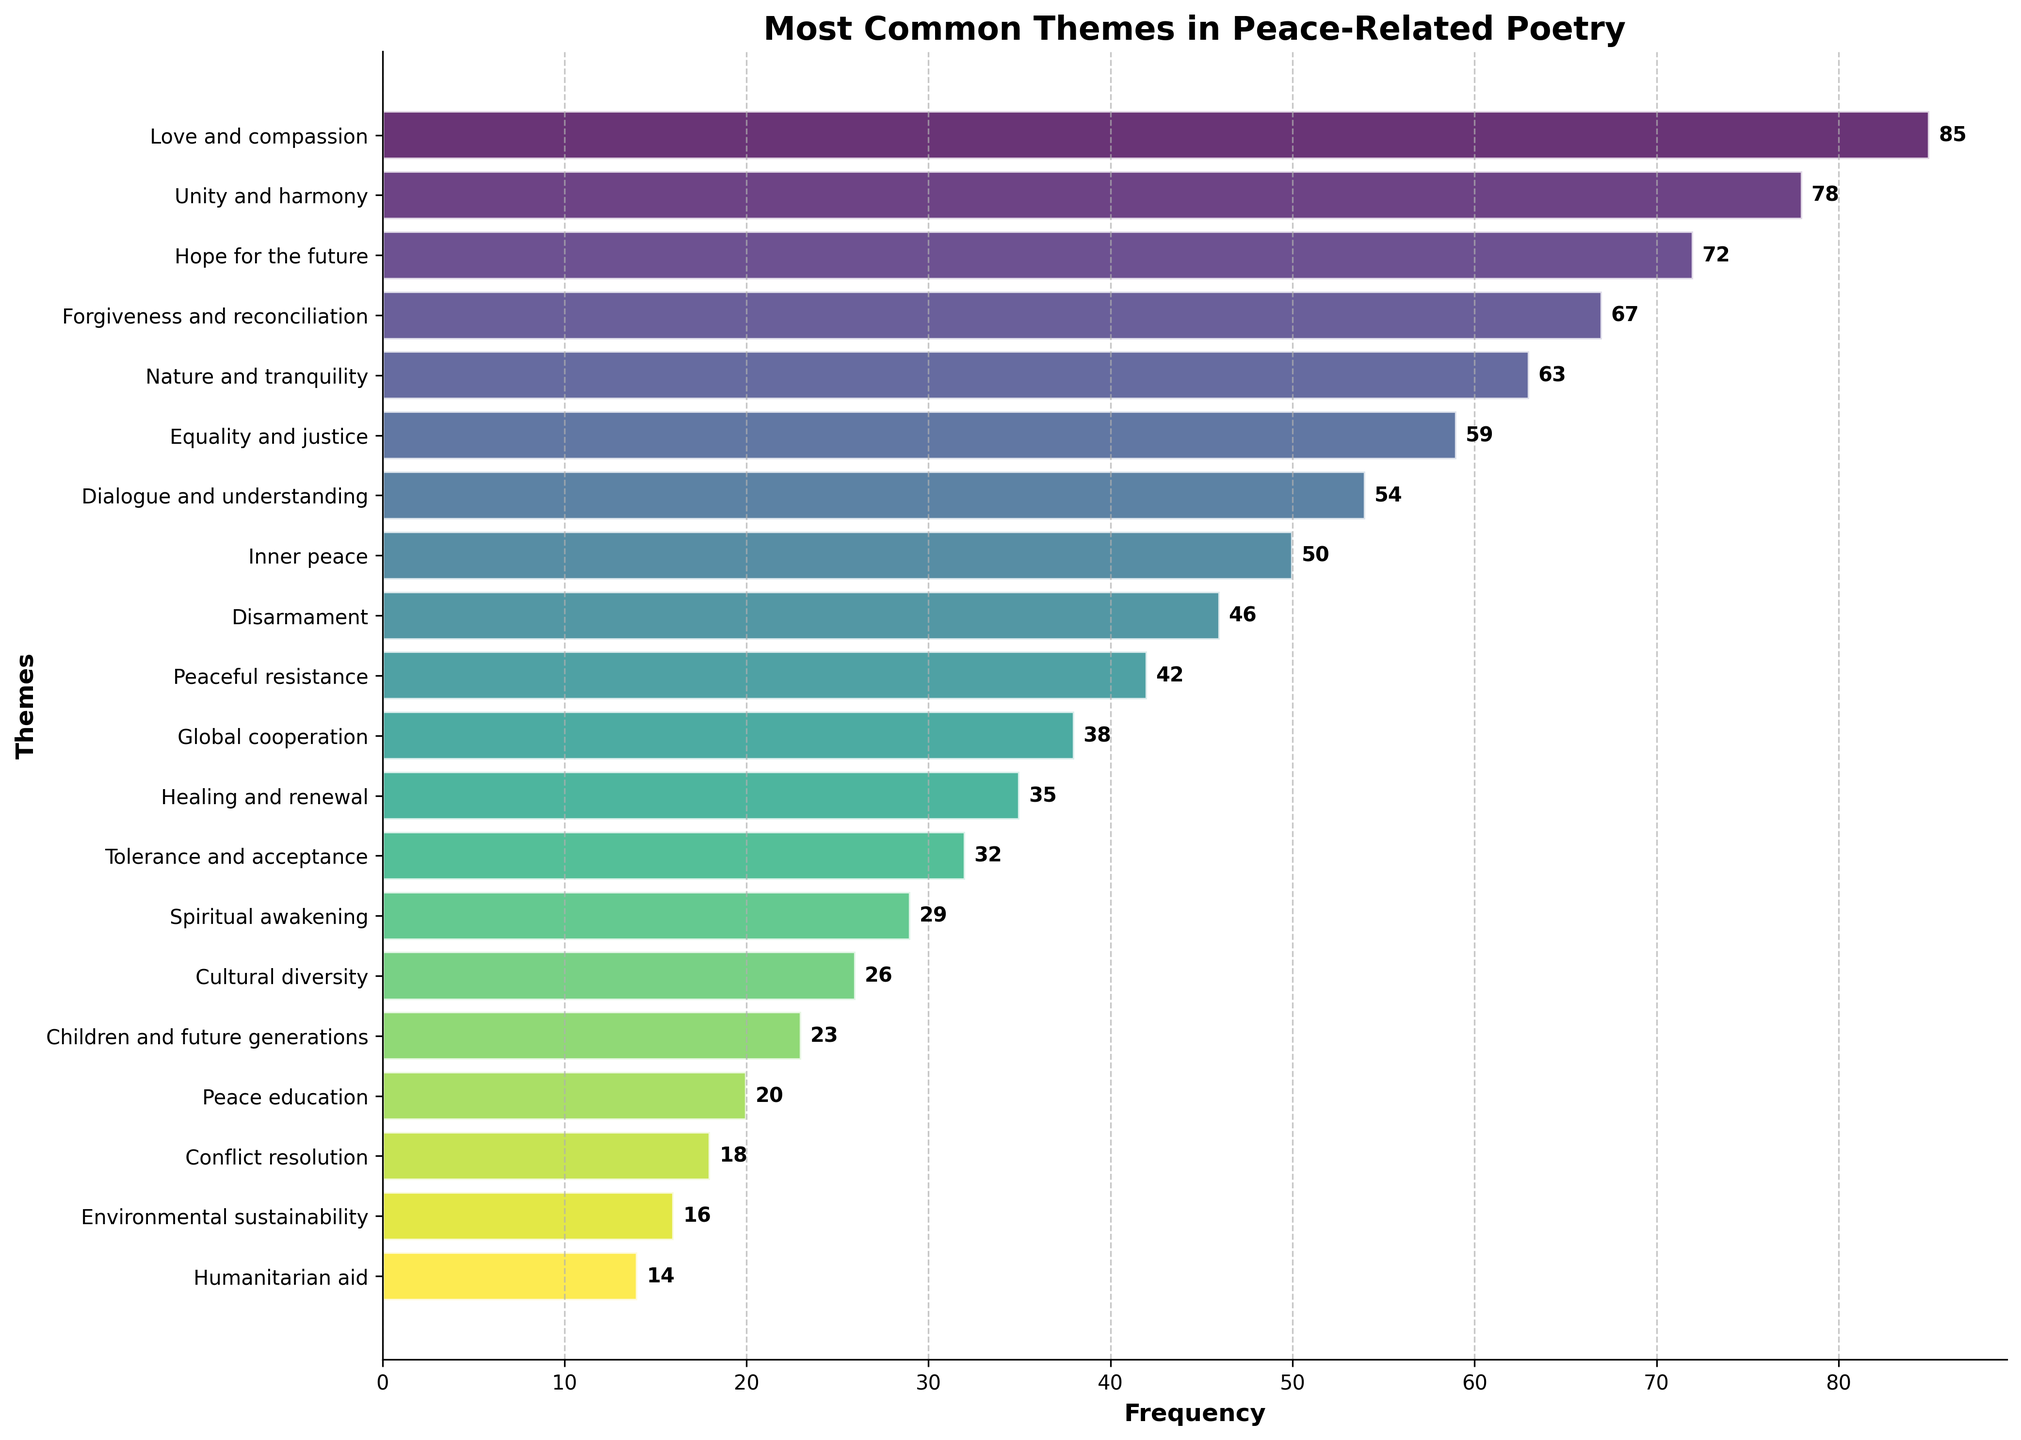What is the most common theme in peace-related poetry? The bar chart shows the frequency of different themes. The theme with the highest frequency is the most common one.
Answer: Love and compassion Which theme is more frequent: Inner peace or Global cooperation? By looking at the lengths of the bars, we can compare their frequencies. Inner peace has a frequency of 50, while Global cooperation has a frequency of 38.
Answer: Inner peace What is the total frequency of the top three themes combined? The top three themes are Love and compassion (85), Unity and harmony (78), and Hope for the future (72). Adding their frequencies: 85 + 78 + 72 = 235
Answer: 235 What is the median frequency value among all themes? First, list all frequencies in ascending order: 14, 16, 18, 20, 23, 26, 29, 32, 35, 38, 42, 46, 50, 54, 59, 63, 67, 72, 78, 85. There are 20 themes, so the median is the average of the 10th and 11th values: (38 + 42) / 2 = 40
Answer: 40 How many themes have a frequency greater than or equal to 50? By inspecting the bar chart, we see that the themes with frequencies 50 or more are: Love and compassion, Unity and harmony, Hope for the future, Forgiveness and reconciliation, Nature and tranquility, Equality and justice, and Dialogue and understanding. That's 7 themes.
Answer: 7 What is the difference in frequency between the themes of Environmental sustainability and Peace education? From the chart, Peace education has a frequency of 20, and Environmental sustainability has a frequency of 16. The difference is 20 - 16 = 4
Answer: 4 Which theme has the shortest bar? The shortest bar represents the theme with the lowest frequency, which is Humanitarian aid.
Answer: Humanitarian aid How does Forgiveness and reconciliation compare in frequency to Peaceful resistance? The frequency of Forgiveness and reconciliation is 67, while Peaceful resistance has a frequency of 42. Therefore, Forgiveness and reconciliation has a higher frequency.
Answer: Forgiveness and reconciliation What is the total frequency of all themes related to future generations (Hope for the future + Children and future generations)? The frequencies are: Hope for the future (72), and Children and future generations (23). Adding them gives: 72 + 23 = 95
Answer: 95 